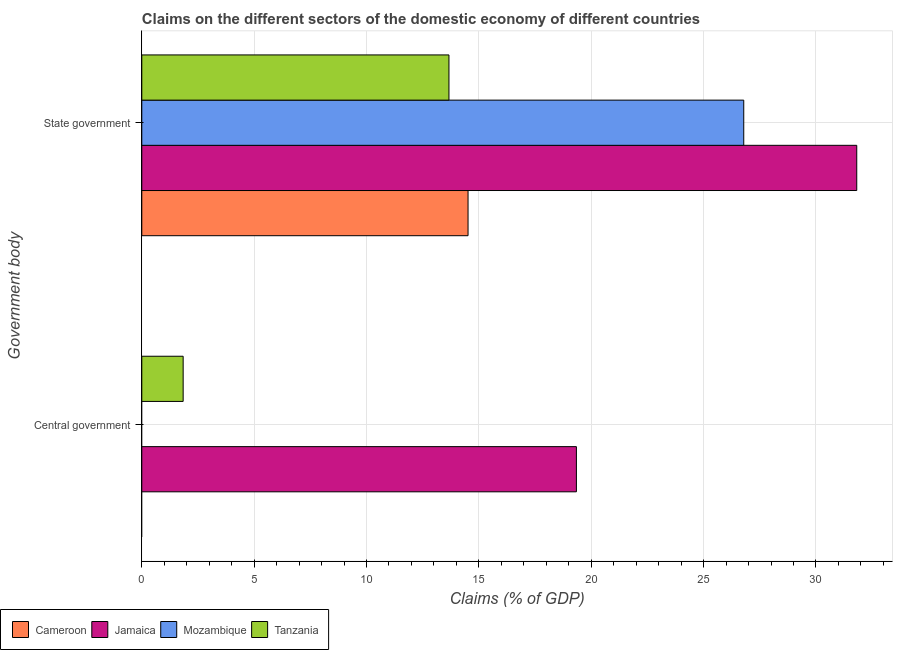Are the number of bars per tick equal to the number of legend labels?
Make the answer very short. No. What is the label of the 2nd group of bars from the top?
Make the answer very short. Central government. What is the claims on state government in Jamaica?
Your answer should be very brief. 31.82. Across all countries, what is the maximum claims on central government?
Your answer should be compact. 19.34. Across all countries, what is the minimum claims on central government?
Make the answer very short. 0. In which country was the claims on central government maximum?
Give a very brief answer. Jamaica. What is the total claims on state government in the graph?
Your answer should be compact. 86.79. What is the difference between the claims on state government in Tanzania and that in Cameroon?
Your response must be concise. -0.85. What is the difference between the claims on central government in Tanzania and the claims on state government in Mozambique?
Your answer should be very brief. -24.95. What is the average claims on central government per country?
Provide a succinct answer. 5.3. What is the difference between the claims on state government and claims on central government in Tanzania?
Provide a short and direct response. 11.83. In how many countries, is the claims on central government greater than 9 %?
Keep it short and to the point. 1. What is the ratio of the claims on state government in Jamaica to that in Mozambique?
Your answer should be very brief. 1.19. Is the claims on state government in Mozambique less than that in Jamaica?
Keep it short and to the point. Yes. In how many countries, is the claims on central government greater than the average claims on central government taken over all countries?
Your answer should be compact. 1. How many bars are there?
Give a very brief answer. 6. What is the difference between two consecutive major ticks on the X-axis?
Keep it short and to the point. 5. Where does the legend appear in the graph?
Your response must be concise. Bottom left. How many legend labels are there?
Provide a succinct answer. 4. How are the legend labels stacked?
Provide a succinct answer. Horizontal. What is the title of the graph?
Provide a succinct answer. Claims on the different sectors of the domestic economy of different countries. What is the label or title of the X-axis?
Provide a short and direct response. Claims (% of GDP). What is the label or title of the Y-axis?
Provide a short and direct response. Government body. What is the Claims (% of GDP) of Cameroon in Central government?
Ensure brevity in your answer.  0. What is the Claims (% of GDP) in Jamaica in Central government?
Your answer should be compact. 19.34. What is the Claims (% of GDP) in Mozambique in Central government?
Make the answer very short. 0. What is the Claims (% of GDP) in Tanzania in Central government?
Keep it short and to the point. 1.84. What is the Claims (% of GDP) of Cameroon in State government?
Make the answer very short. 14.52. What is the Claims (% of GDP) of Jamaica in State government?
Offer a terse response. 31.82. What is the Claims (% of GDP) of Mozambique in State government?
Offer a very short reply. 26.79. What is the Claims (% of GDP) in Tanzania in State government?
Offer a terse response. 13.67. Across all Government body, what is the maximum Claims (% of GDP) in Cameroon?
Ensure brevity in your answer.  14.52. Across all Government body, what is the maximum Claims (% of GDP) of Jamaica?
Your response must be concise. 31.82. Across all Government body, what is the maximum Claims (% of GDP) in Mozambique?
Your answer should be very brief. 26.79. Across all Government body, what is the maximum Claims (% of GDP) in Tanzania?
Make the answer very short. 13.67. Across all Government body, what is the minimum Claims (% of GDP) of Jamaica?
Offer a very short reply. 19.34. Across all Government body, what is the minimum Claims (% of GDP) of Mozambique?
Your response must be concise. 0. Across all Government body, what is the minimum Claims (% of GDP) in Tanzania?
Your response must be concise. 1.84. What is the total Claims (% of GDP) in Cameroon in the graph?
Offer a very short reply. 14.52. What is the total Claims (% of GDP) of Jamaica in the graph?
Offer a very short reply. 51.16. What is the total Claims (% of GDP) in Mozambique in the graph?
Offer a terse response. 26.79. What is the total Claims (% of GDP) in Tanzania in the graph?
Your answer should be very brief. 15.51. What is the difference between the Claims (% of GDP) in Jamaica in Central government and that in State government?
Offer a very short reply. -12.48. What is the difference between the Claims (% of GDP) of Tanzania in Central government and that in State government?
Offer a very short reply. -11.83. What is the difference between the Claims (% of GDP) of Jamaica in Central government and the Claims (% of GDP) of Mozambique in State government?
Provide a short and direct response. -7.45. What is the difference between the Claims (% of GDP) of Jamaica in Central government and the Claims (% of GDP) of Tanzania in State government?
Make the answer very short. 5.67. What is the average Claims (% of GDP) in Cameroon per Government body?
Your response must be concise. 7.26. What is the average Claims (% of GDP) of Jamaica per Government body?
Provide a succinct answer. 25.58. What is the average Claims (% of GDP) in Mozambique per Government body?
Keep it short and to the point. 13.39. What is the average Claims (% of GDP) in Tanzania per Government body?
Provide a succinct answer. 7.75. What is the difference between the Claims (% of GDP) of Jamaica and Claims (% of GDP) of Tanzania in Central government?
Provide a succinct answer. 17.5. What is the difference between the Claims (% of GDP) of Cameroon and Claims (% of GDP) of Jamaica in State government?
Ensure brevity in your answer.  -17.3. What is the difference between the Claims (% of GDP) of Cameroon and Claims (% of GDP) of Mozambique in State government?
Provide a short and direct response. -12.27. What is the difference between the Claims (% of GDP) of Cameroon and Claims (% of GDP) of Tanzania in State government?
Ensure brevity in your answer.  0.85. What is the difference between the Claims (% of GDP) in Jamaica and Claims (% of GDP) in Mozambique in State government?
Your answer should be compact. 5.03. What is the difference between the Claims (% of GDP) of Jamaica and Claims (% of GDP) of Tanzania in State government?
Make the answer very short. 18.15. What is the difference between the Claims (% of GDP) of Mozambique and Claims (% of GDP) of Tanzania in State government?
Provide a succinct answer. 13.12. What is the ratio of the Claims (% of GDP) in Jamaica in Central government to that in State government?
Keep it short and to the point. 0.61. What is the ratio of the Claims (% of GDP) in Tanzania in Central government to that in State government?
Keep it short and to the point. 0.13. What is the difference between the highest and the second highest Claims (% of GDP) of Jamaica?
Ensure brevity in your answer.  12.48. What is the difference between the highest and the second highest Claims (% of GDP) of Tanzania?
Offer a very short reply. 11.83. What is the difference between the highest and the lowest Claims (% of GDP) of Cameroon?
Your answer should be very brief. 14.52. What is the difference between the highest and the lowest Claims (% of GDP) of Jamaica?
Ensure brevity in your answer.  12.48. What is the difference between the highest and the lowest Claims (% of GDP) in Mozambique?
Keep it short and to the point. 26.79. What is the difference between the highest and the lowest Claims (% of GDP) of Tanzania?
Your answer should be compact. 11.83. 